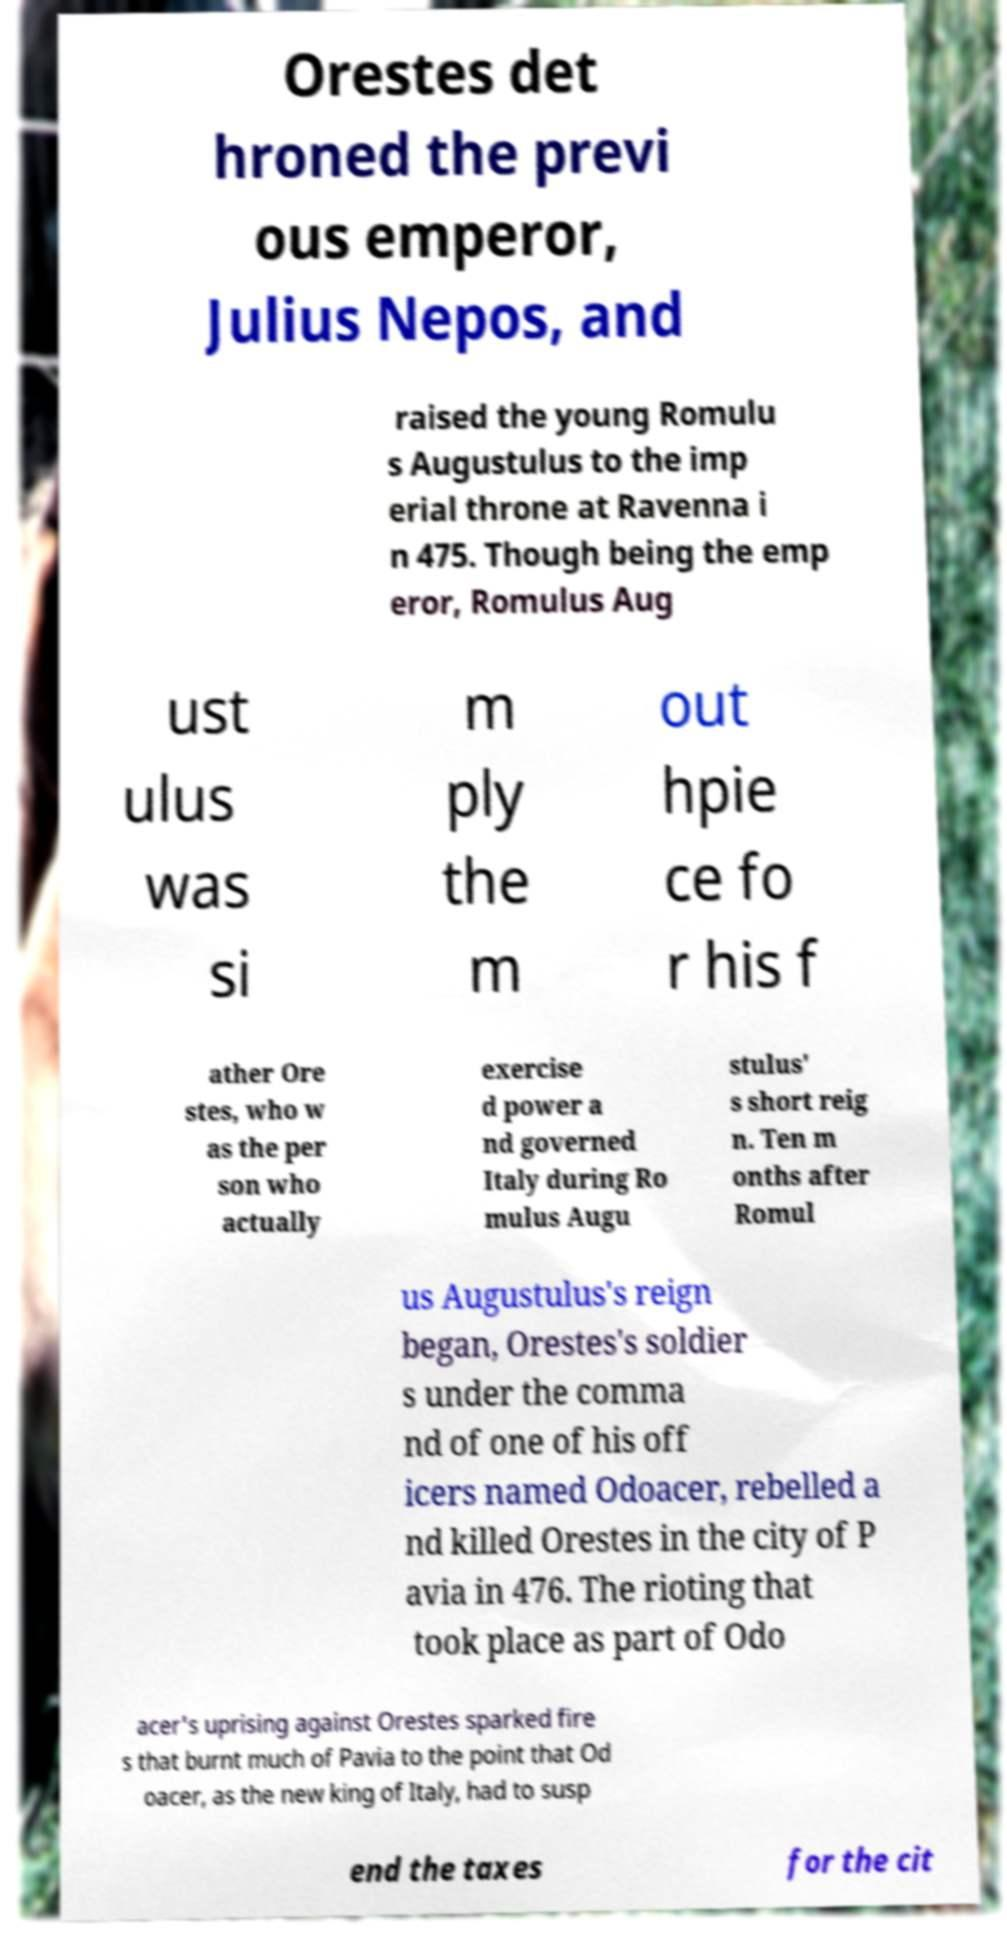Can you read and provide the text displayed in the image?This photo seems to have some interesting text. Can you extract and type it out for me? Orestes det hroned the previ ous emperor, Julius Nepos, and raised the young Romulu s Augustulus to the imp erial throne at Ravenna i n 475. Though being the emp eror, Romulus Aug ust ulus was si m ply the m out hpie ce fo r his f ather Ore stes, who w as the per son who actually exercise d power a nd governed Italy during Ro mulus Augu stulus' s short reig n. Ten m onths after Romul us Augustulus's reign began, Orestes's soldier s under the comma nd of one of his off icers named Odoacer, rebelled a nd killed Orestes in the city of P avia in 476. The rioting that took place as part of Odo acer's uprising against Orestes sparked fire s that burnt much of Pavia to the point that Od oacer, as the new king of Italy, had to susp end the taxes for the cit 